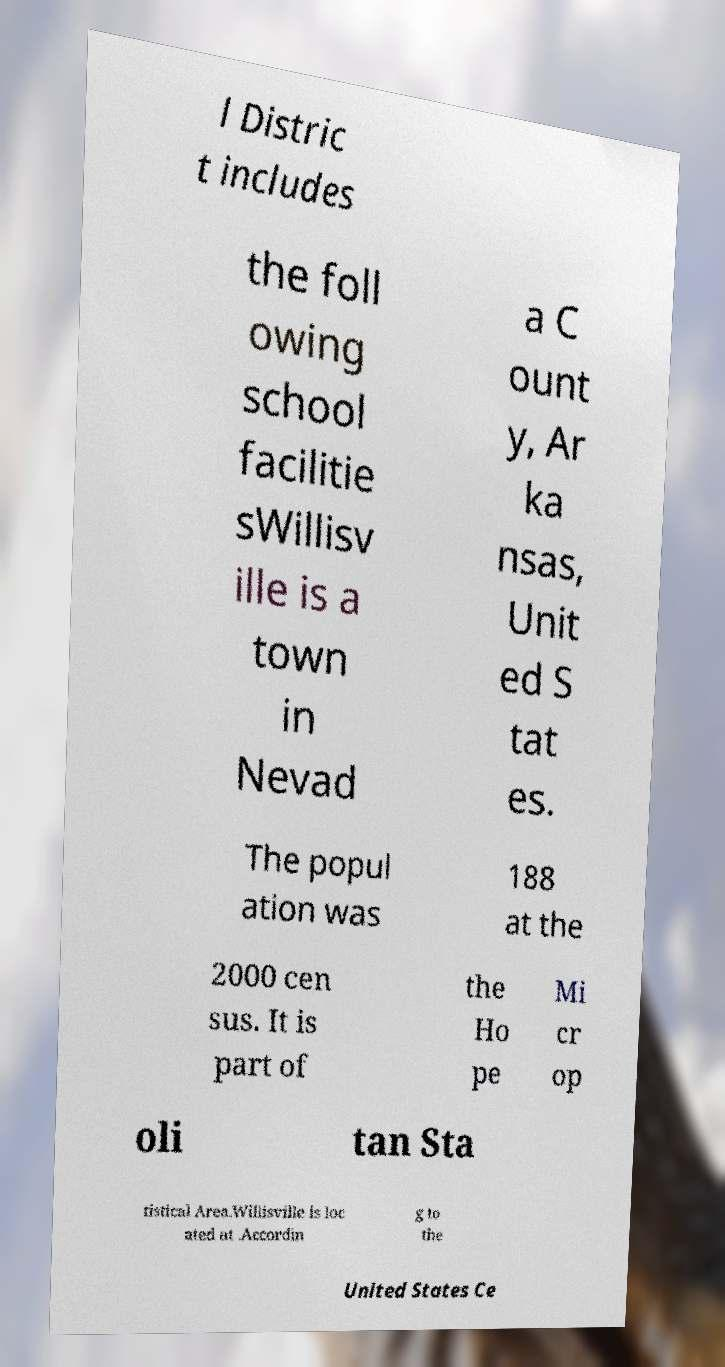Please read and relay the text visible in this image. What does it say? l Distric t includes the foll owing school facilitie sWillisv ille is a town in Nevad a C ount y, Ar ka nsas, Unit ed S tat es. The popul ation was 188 at the 2000 cen sus. It is part of the Ho pe Mi cr op oli tan Sta tistical Area.Willisville is loc ated at .Accordin g to the United States Ce 